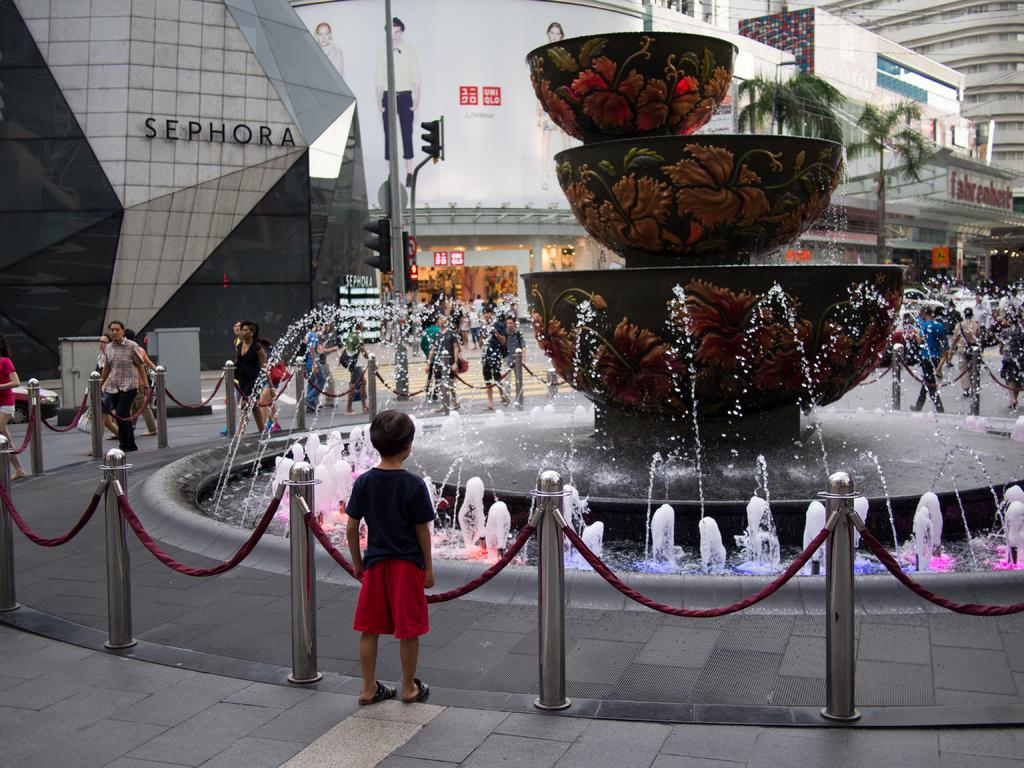<image>
Provide a brief description of the given image. A child is looking at a fountain in front of a Sephora store. 